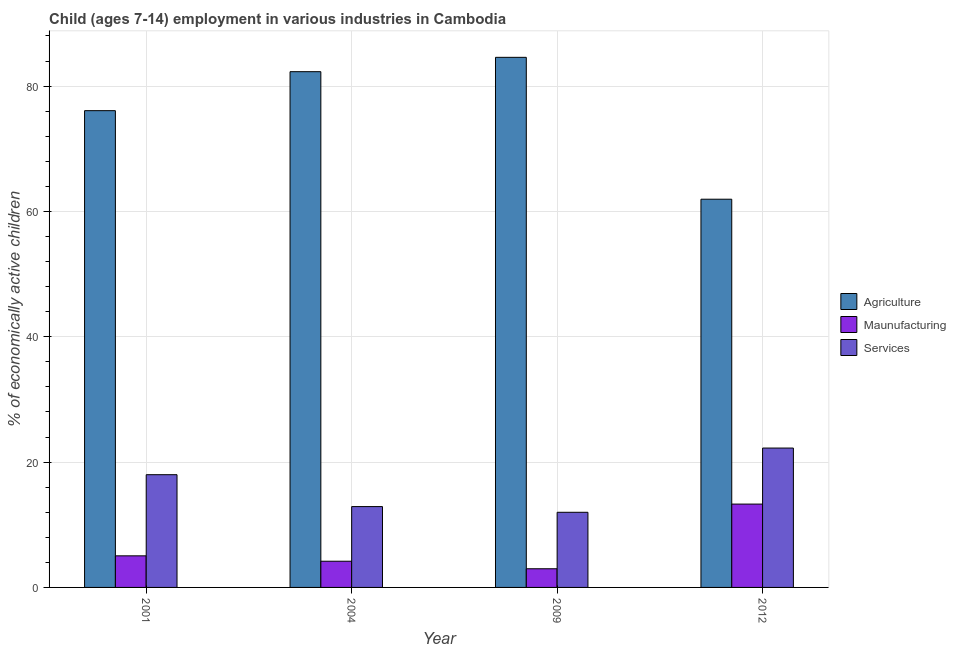How many different coloured bars are there?
Your response must be concise. 3. How many groups of bars are there?
Provide a short and direct response. 4. Are the number of bars on each tick of the X-axis equal?
Your answer should be compact. Yes. How many bars are there on the 2nd tick from the left?
Offer a terse response. 3. What is the label of the 4th group of bars from the left?
Your response must be concise. 2012. Across all years, what is the maximum percentage of economically active children in services?
Provide a succinct answer. 22.24. Across all years, what is the minimum percentage of economically active children in services?
Provide a succinct answer. 11.99. What is the total percentage of economically active children in agriculture in the graph?
Keep it short and to the point. 304.92. What is the difference between the percentage of economically active children in services in 2009 and that in 2012?
Provide a short and direct response. -10.25. What is the difference between the percentage of economically active children in agriculture in 2001 and the percentage of economically active children in manufacturing in 2004?
Give a very brief answer. -6.22. What is the average percentage of economically active children in agriculture per year?
Ensure brevity in your answer.  76.23. In the year 2009, what is the difference between the percentage of economically active children in services and percentage of economically active children in agriculture?
Offer a terse response. 0. In how many years, is the percentage of economically active children in agriculture greater than 52 %?
Your answer should be very brief. 4. What is the ratio of the percentage of economically active children in agriculture in 2004 to that in 2009?
Offer a terse response. 0.97. Is the percentage of economically active children in services in 2001 less than that in 2012?
Ensure brevity in your answer.  Yes. What is the difference between the highest and the second highest percentage of economically active children in agriculture?
Provide a succinct answer. 2.29. What is the difference between the highest and the lowest percentage of economically active children in agriculture?
Give a very brief answer. 22.64. Is the sum of the percentage of economically active children in agriculture in 2001 and 2004 greater than the maximum percentage of economically active children in services across all years?
Ensure brevity in your answer.  Yes. What does the 1st bar from the left in 2004 represents?
Keep it short and to the point. Agriculture. What does the 1st bar from the right in 2012 represents?
Provide a short and direct response. Services. Is it the case that in every year, the sum of the percentage of economically active children in agriculture and percentage of economically active children in manufacturing is greater than the percentage of economically active children in services?
Make the answer very short. Yes. How many bars are there?
Ensure brevity in your answer.  12. How many years are there in the graph?
Provide a succinct answer. 4. Are the values on the major ticks of Y-axis written in scientific E-notation?
Offer a terse response. No. Does the graph contain any zero values?
Give a very brief answer. No. Where does the legend appear in the graph?
Provide a short and direct response. Center right. How many legend labels are there?
Give a very brief answer. 3. What is the title of the graph?
Your answer should be compact. Child (ages 7-14) employment in various industries in Cambodia. Does "Secondary education" appear as one of the legend labels in the graph?
Offer a terse response. No. What is the label or title of the Y-axis?
Your answer should be compact. % of economically active children. What is the % of economically active children in Agriculture in 2001?
Your response must be concise. 76.08. What is the % of economically active children of Maunufacturing in 2001?
Keep it short and to the point. 5.04. What is the % of economically active children of Services in 2001?
Make the answer very short. 17.99. What is the % of economically active children in Agriculture in 2004?
Make the answer very short. 82.3. What is the % of economically active children in Maunufacturing in 2004?
Ensure brevity in your answer.  4.18. What is the % of economically active children of Agriculture in 2009?
Offer a very short reply. 84.59. What is the % of economically active children of Maunufacturing in 2009?
Provide a short and direct response. 2.98. What is the % of economically active children of Services in 2009?
Your answer should be compact. 11.99. What is the % of economically active children of Agriculture in 2012?
Make the answer very short. 61.95. What is the % of economically active children in Services in 2012?
Offer a very short reply. 22.24. Across all years, what is the maximum % of economically active children of Agriculture?
Keep it short and to the point. 84.59. Across all years, what is the maximum % of economically active children in Services?
Your answer should be compact. 22.24. Across all years, what is the minimum % of economically active children of Agriculture?
Your response must be concise. 61.95. Across all years, what is the minimum % of economically active children of Maunufacturing?
Your answer should be compact. 2.98. Across all years, what is the minimum % of economically active children of Services?
Give a very brief answer. 11.99. What is the total % of economically active children of Agriculture in the graph?
Provide a succinct answer. 304.92. What is the total % of economically active children of Maunufacturing in the graph?
Provide a short and direct response. 25.5. What is the total % of economically active children of Services in the graph?
Your answer should be very brief. 65.12. What is the difference between the % of economically active children of Agriculture in 2001 and that in 2004?
Keep it short and to the point. -6.22. What is the difference between the % of economically active children in Maunufacturing in 2001 and that in 2004?
Offer a terse response. 0.86. What is the difference between the % of economically active children in Services in 2001 and that in 2004?
Provide a short and direct response. 5.09. What is the difference between the % of economically active children of Agriculture in 2001 and that in 2009?
Ensure brevity in your answer.  -8.51. What is the difference between the % of economically active children in Maunufacturing in 2001 and that in 2009?
Ensure brevity in your answer.  2.06. What is the difference between the % of economically active children of Services in 2001 and that in 2009?
Your answer should be compact. 6. What is the difference between the % of economically active children in Agriculture in 2001 and that in 2012?
Provide a succinct answer. 14.13. What is the difference between the % of economically active children in Maunufacturing in 2001 and that in 2012?
Offer a terse response. -8.26. What is the difference between the % of economically active children of Services in 2001 and that in 2012?
Offer a very short reply. -4.25. What is the difference between the % of economically active children in Agriculture in 2004 and that in 2009?
Ensure brevity in your answer.  -2.29. What is the difference between the % of economically active children of Services in 2004 and that in 2009?
Your answer should be compact. 0.91. What is the difference between the % of economically active children in Agriculture in 2004 and that in 2012?
Provide a short and direct response. 20.35. What is the difference between the % of economically active children in Maunufacturing in 2004 and that in 2012?
Offer a very short reply. -9.12. What is the difference between the % of economically active children of Services in 2004 and that in 2012?
Give a very brief answer. -9.34. What is the difference between the % of economically active children in Agriculture in 2009 and that in 2012?
Provide a short and direct response. 22.64. What is the difference between the % of economically active children in Maunufacturing in 2009 and that in 2012?
Your answer should be very brief. -10.32. What is the difference between the % of economically active children in Services in 2009 and that in 2012?
Ensure brevity in your answer.  -10.25. What is the difference between the % of economically active children in Agriculture in 2001 and the % of economically active children in Maunufacturing in 2004?
Your answer should be very brief. 71.9. What is the difference between the % of economically active children in Agriculture in 2001 and the % of economically active children in Services in 2004?
Offer a terse response. 63.18. What is the difference between the % of economically active children in Maunufacturing in 2001 and the % of economically active children in Services in 2004?
Your answer should be very brief. -7.86. What is the difference between the % of economically active children in Agriculture in 2001 and the % of economically active children in Maunufacturing in 2009?
Give a very brief answer. 73.1. What is the difference between the % of economically active children of Agriculture in 2001 and the % of economically active children of Services in 2009?
Make the answer very short. 64.09. What is the difference between the % of economically active children of Maunufacturing in 2001 and the % of economically active children of Services in 2009?
Make the answer very short. -6.95. What is the difference between the % of economically active children of Agriculture in 2001 and the % of economically active children of Maunufacturing in 2012?
Provide a succinct answer. 62.78. What is the difference between the % of economically active children of Agriculture in 2001 and the % of economically active children of Services in 2012?
Offer a terse response. 53.84. What is the difference between the % of economically active children of Maunufacturing in 2001 and the % of economically active children of Services in 2012?
Make the answer very short. -17.2. What is the difference between the % of economically active children in Agriculture in 2004 and the % of economically active children in Maunufacturing in 2009?
Offer a very short reply. 79.32. What is the difference between the % of economically active children of Agriculture in 2004 and the % of economically active children of Services in 2009?
Your response must be concise. 70.31. What is the difference between the % of economically active children in Maunufacturing in 2004 and the % of economically active children in Services in 2009?
Offer a very short reply. -7.81. What is the difference between the % of economically active children of Agriculture in 2004 and the % of economically active children of Maunufacturing in 2012?
Ensure brevity in your answer.  69. What is the difference between the % of economically active children in Agriculture in 2004 and the % of economically active children in Services in 2012?
Your response must be concise. 60.06. What is the difference between the % of economically active children of Maunufacturing in 2004 and the % of economically active children of Services in 2012?
Ensure brevity in your answer.  -18.06. What is the difference between the % of economically active children of Agriculture in 2009 and the % of economically active children of Maunufacturing in 2012?
Your answer should be compact. 71.29. What is the difference between the % of economically active children in Agriculture in 2009 and the % of economically active children in Services in 2012?
Provide a succinct answer. 62.35. What is the difference between the % of economically active children in Maunufacturing in 2009 and the % of economically active children in Services in 2012?
Provide a short and direct response. -19.26. What is the average % of economically active children of Agriculture per year?
Your response must be concise. 76.23. What is the average % of economically active children of Maunufacturing per year?
Your answer should be very brief. 6.38. What is the average % of economically active children of Services per year?
Make the answer very short. 16.28. In the year 2001, what is the difference between the % of economically active children of Agriculture and % of economically active children of Maunufacturing?
Make the answer very short. 71.04. In the year 2001, what is the difference between the % of economically active children of Agriculture and % of economically active children of Services?
Provide a short and direct response. 58.09. In the year 2001, what is the difference between the % of economically active children in Maunufacturing and % of economically active children in Services?
Offer a very short reply. -12.95. In the year 2004, what is the difference between the % of economically active children of Agriculture and % of economically active children of Maunufacturing?
Make the answer very short. 78.12. In the year 2004, what is the difference between the % of economically active children of Agriculture and % of economically active children of Services?
Give a very brief answer. 69.4. In the year 2004, what is the difference between the % of economically active children in Maunufacturing and % of economically active children in Services?
Your answer should be very brief. -8.72. In the year 2009, what is the difference between the % of economically active children of Agriculture and % of economically active children of Maunufacturing?
Give a very brief answer. 81.61. In the year 2009, what is the difference between the % of economically active children in Agriculture and % of economically active children in Services?
Offer a very short reply. 72.6. In the year 2009, what is the difference between the % of economically active children in Maunufacturing and % of economically active children in Services?
Give a very brief answer. -9.01. In the year 2012, what is the difference between the % of economically active children of Agriculture and % of economically active children of Maunufacturing?
Keep it short and to the point. 48.65. In the year 2012, what is the difference between the % of economically active children of Agriculture and % of economically active children of Services?
Keep it short and to the point. 39.71. In the year 2012, what is the difference between the % of economically active children of Maunufacturing and % of economically active children of Services?
Your answer should be very brief. -8.94. What is the ratio of the % of economically active children of Agriculture in 2001 to that in 2004?
Your answer should be compact. 0.92. What is the ratio of the % of economically active children in Maunufacturing in 2001 to that in 2004?
Ensure brevity in your answer.  1.21. What is the ratio of the % of economically active children in Services in 2001 to that in 2004?
Provide a short and direct response. 1.39. What is the ratio of the % of economically active children in Agriculture in 2001 to that in 2009?
Provide a succinct answer. 0.9. What is the ratio of the % of economically active children of Maunufacturing in 2001 to that in 2009?
Provide a succinct answer. 1.69. What is the ratio of the % of economically active children of Services in 2001 to that in 2009?
Provide a short and direct response. 1.5. What is the ratio of the % of economically active children of Agriculture in 2001 to that in 2012?
Keep it short and to the point. 1.23. What is the ratio of the % of economically active children in Maunufacturing in 2001 to that in 2012?
Your response must be concise. 0.38. What is the ratio of the % of economically active children in Services in 2001 to that in 2012?
Keep it short and to the point. 0.81. What is the ratio of the % of economically active children of Agriculture in 2004 to that in 2009?
Your response must be concise. 0.97. What is the ratio of the % of economically active children of Maunufacturing in 2004 to that in 2009?
Provide a short and direct response. 1.4. What is the ratio of the % of economically active children in Services in 2004 to that in 2009?
Your response must be concise. 1.08. What is the ratio of the % of economically active children in Agriculture in 2004 to that in 2012?
Your response must be concise. 1.33. What is the ratio of the % of economically active children in Maunufacturing in 2004 to that in 2012?
Give a very brief answer. 0.31. What is the ratio of the % of economically active children of Services in 2004 to that in 2012?
Provide a short and direct response. 0.58. What is the ratio of the % of economically active children in Agriculture in 2009 to that in 2012?
Keep it short and to the point. 1.37. What is the ratio of the % of economically active children in Maunufacturing in 2009 to that in 2012?
Your answer should be compact. 0.22. What is the ratio of the % of economically active children in Services in 2009 to that in 2012?
Your response must be concise. 0.54. What is the difference between the highest and the second highest % of economically active children in Agriculture?
Ensure brevity in your answer.  2.29. What is the difference between the highest and the second highest % of economically active children of Maunufacturing?
Your answer should be very brief. 8.26. What is the difference between the highest and the second highest % of economically active children in Services?
Your answer should be compact. 4.25. What is the difference between the highest and the lowest % of economically active children in Agriculture?
Ensure brevity in your answer.  22.64. What is the difference between the highest and the lowest % of economically active children in Maunufacturing?
Offer a very short reply. 10.32. What is the difference between the highest and the lowest % of economically active children of Services?
Ensure brevity in your answer.  10.25. 